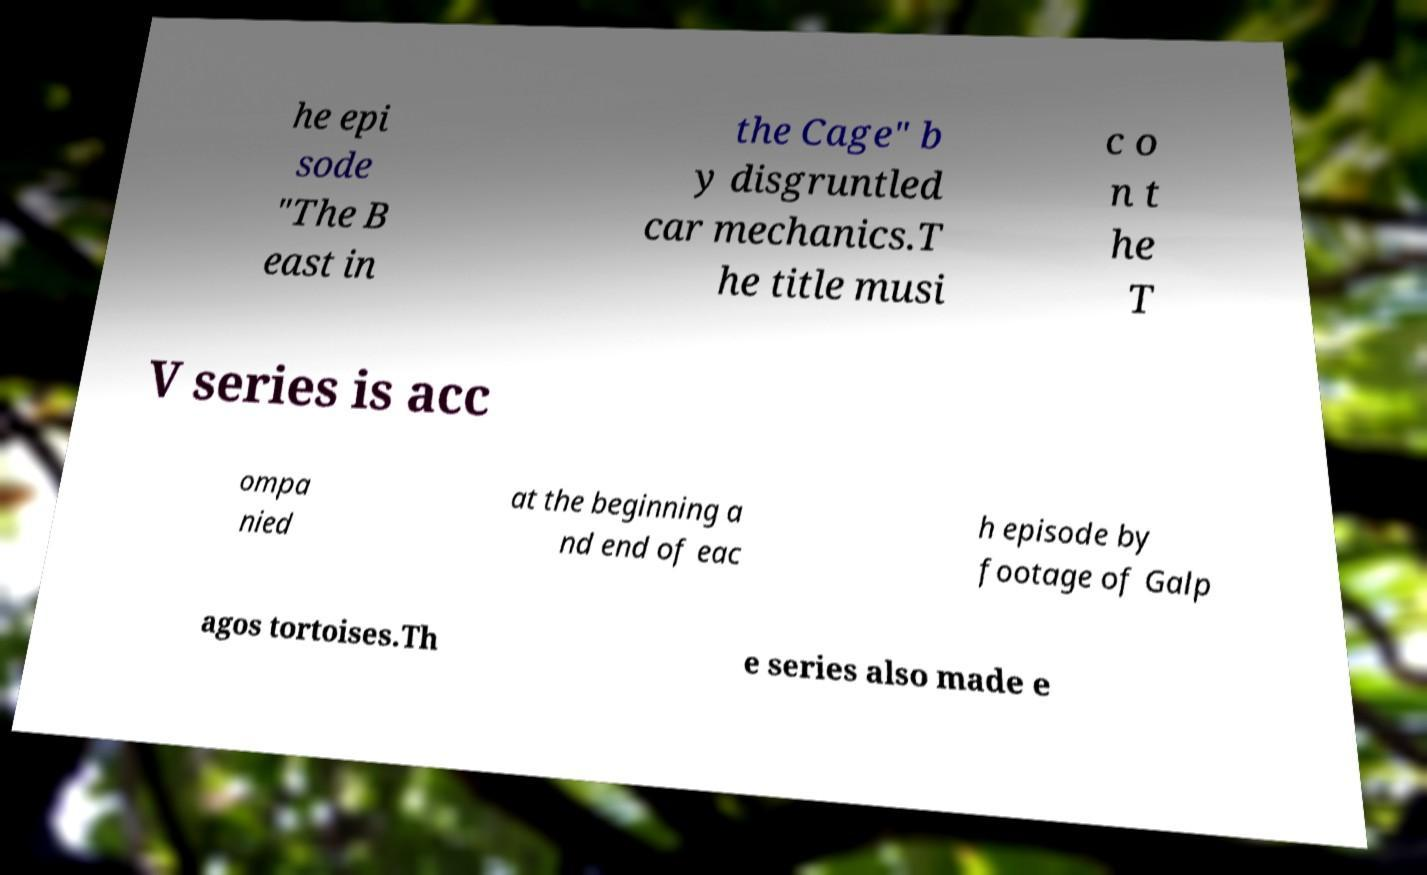Can you read and provide the text displayed in the image?This photo seems to have some interesting text. Can you extract and type it out for me? he epi sode "The B east in the Cage" b y disgruntled car mechanics.T he title musi c o n t he T V series is acc ompa nied at the beginning a nd end of eac h episode by footage of Galp agos tortoises.Th e series also made e 